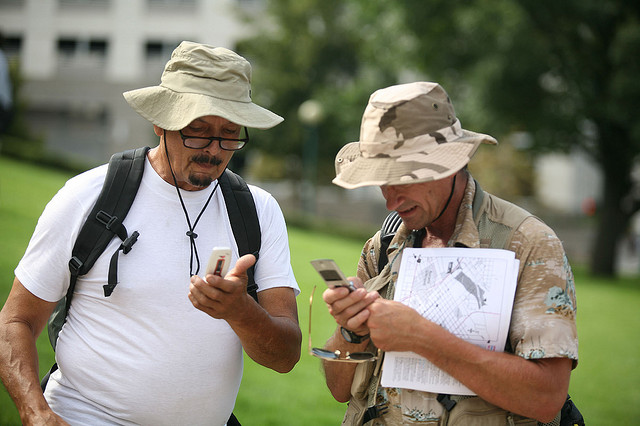<image>What are the men's ranks? I don't know. The men's ranks are not clearly identifiable. They could be 'major', 'privates', 'civilians', 'scoutmasters', or 'captains'. What are the men's ranks? I don't know what the men's ranks are. It can be major, privates, scoutmasters, captains or no rank. 